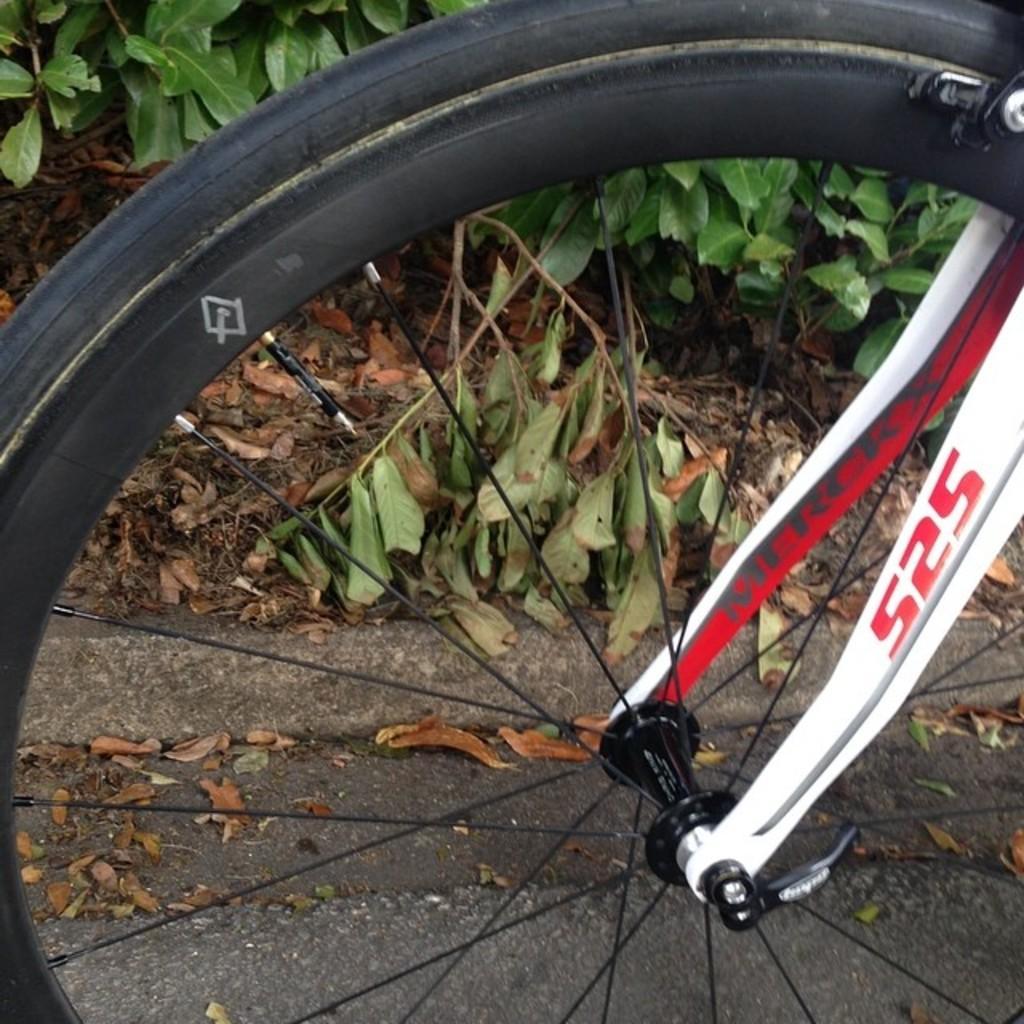Describe this image in one or two sentences. In this picture I can see there is a wheel and it is attached to the wheel and there are few dry leaves on the floor and in the backdrop there are plants. 